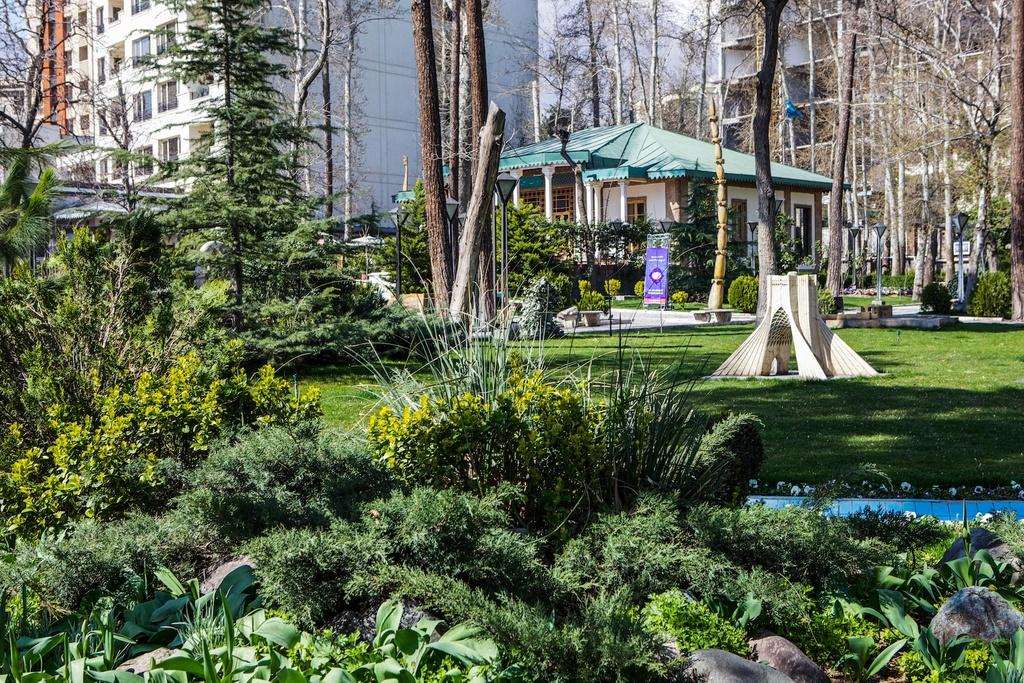What is the main subject in the center of the image? There are buildings in the center of the image. What feature do the buildings have? The buildings have windows. What type of vegetation can be seen in the image? There are trees, plants, and grass in the image. What other objects are present in the image? There are poles, rocks, and a banner in the image. Can you describe the other objects in the image? There are a few other objects in the image, but their specific details are not mentioned in the provided facts. What invention is being demonstrated in the image? There is no invention being demonstrated in the image; it primarily features buildings, trees, plants, grass, poles, rocks, and a banner. What shape is the side of the building on the left side of the image? The provided facts do not mention the shape of any building sides, so it cannot be determined from the image. 